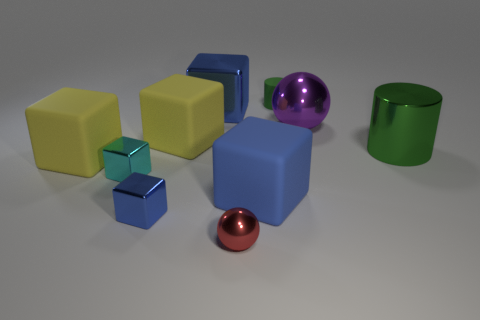Can you tell me the colors of the cubes in the image? Yes, in the image there are cubes in three different colors: yellow, green, and blue. 